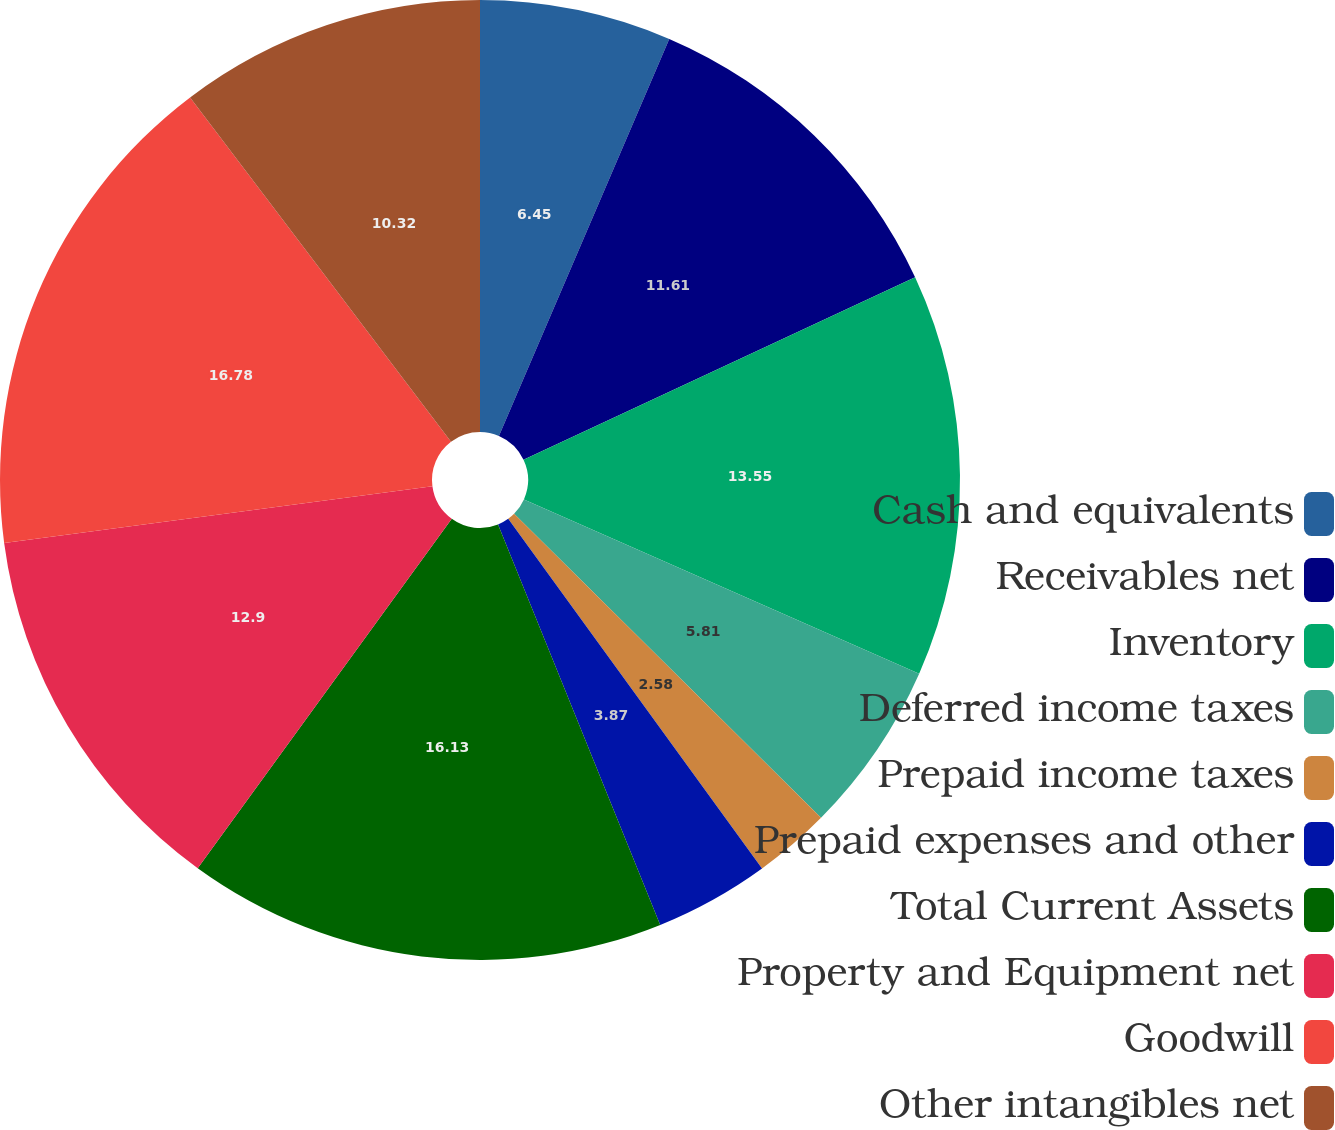<chart> <loc_0><loc_0><loc_500><loc_500><pie_chart><fcel>Cash and equivalents<fcel>Receivables net<fcel>Inventory<fcel>Deferred income taxes<fcel>Prepaid income taxes<fcel>Prepaid expenses and other<fcel>Total Current Assets<fcel>Property and Equipment net<fcel>Goodwill<fcel>Other intangibles net<nl><fcel>6.45%<fcel>11.61%<fcel>13.55%<fcel>5.81%<fcel>2.58%<fcel>3.87%<fcel>16.13%<fcel>12.9%<fcel>16.77%<fcel>10.32%<nl></chart> 